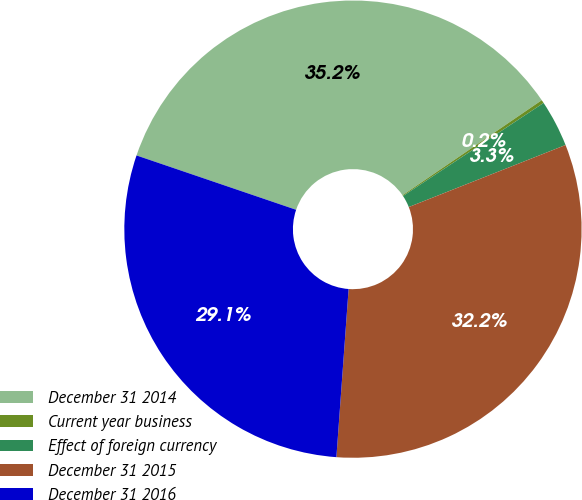Convert chart to OTSL. <chart><loc_0><loc_0><loc_500><loc_500><pie_chart><fcel>December 31 2014<fcel>Current year business<fcel>Effect of foreign currency<fcel>December 31 2015<fcel>December 31 2016<nl><fcel>35.24%<fcel>0.23%<fcel>3.31%<fcel>32.15%<fcel>29.07%<nl></chart> 